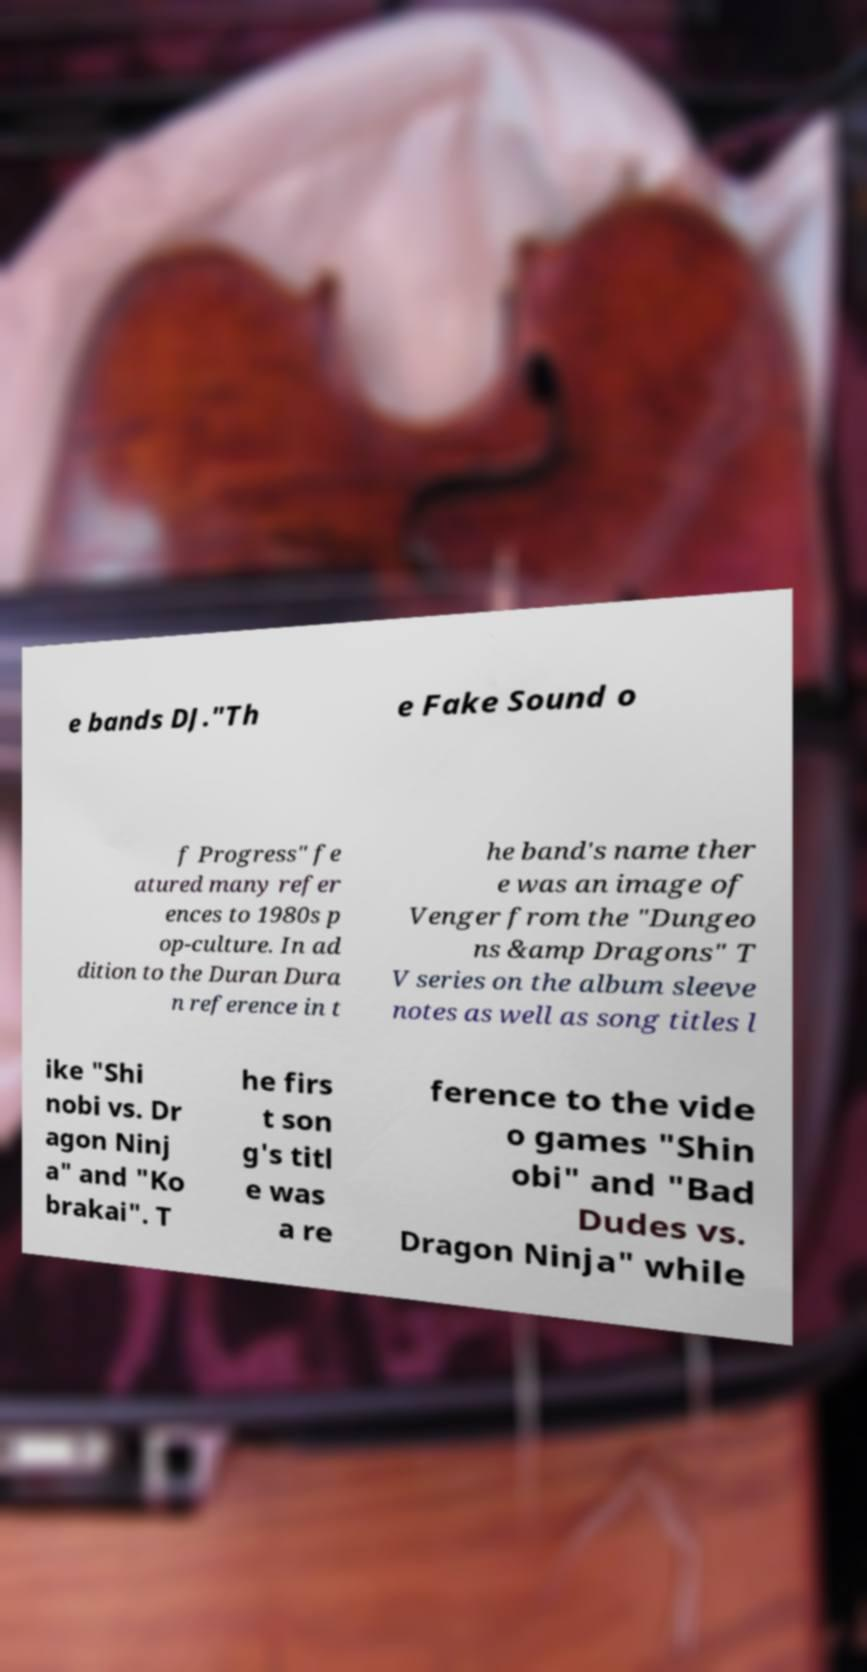Can you accurately transcribe the text from the provided image for me? e bands DJ."Th e Fake Sound o f Progress" fe atured many refer ences to 1980s p op-culture. In ad dition to the Duran Dura n reference in t he band's name ther e was an image of Venger from the "Dungeo ns &amp Dragons" T V series on the album sleeve notes as well as song titles l ike "Shi nobi vs. Dr agon Ninj a" and "Ko brakai". T he firs t son g's titl e was a re ference to the vide o games "Shin obi" and "Bad Dudes vs. Dragon Ninja" while 